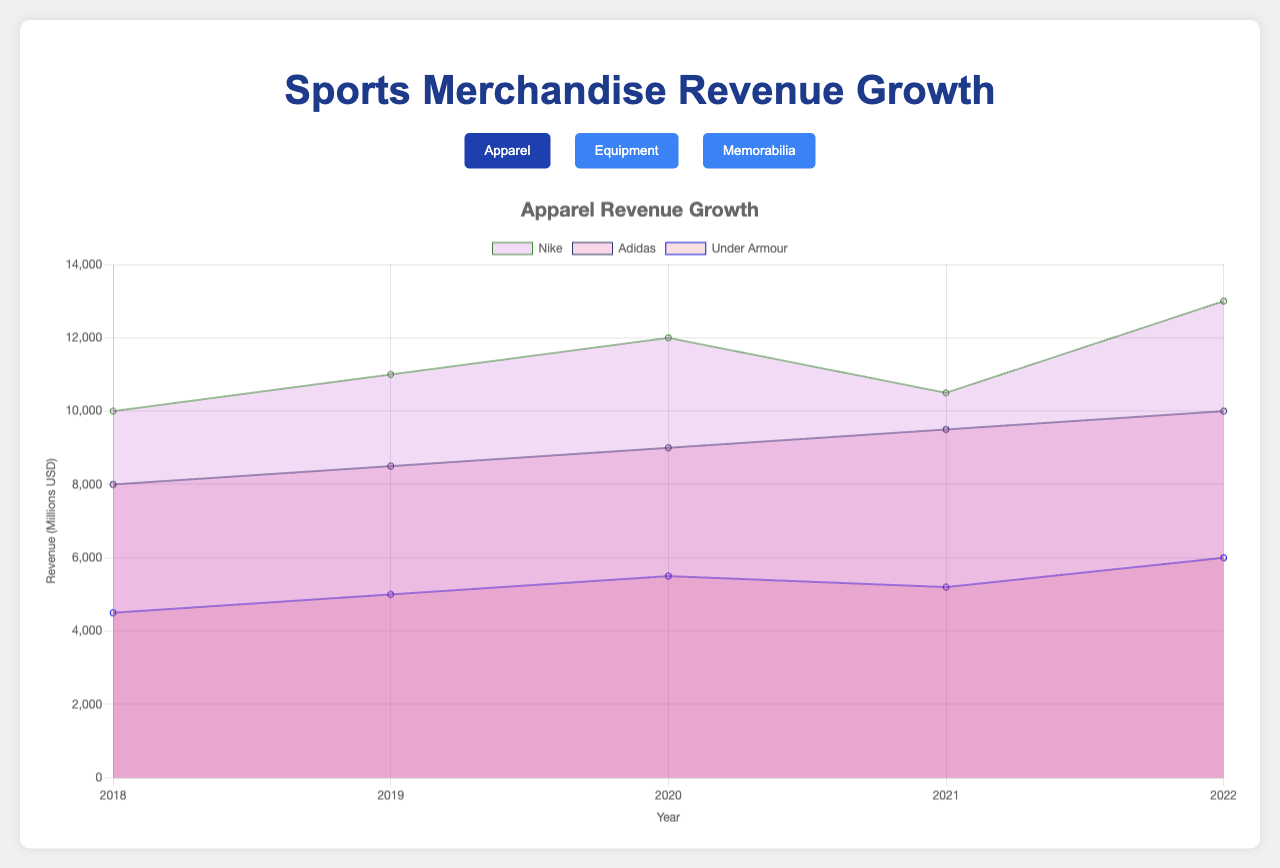Which company in the Apparel category had the highest revenue in 2022? Look for the Apparel category in the legend, then check the revenue values for each company in 2022. Nike's revenue in 2022 stands at 13000, which is higher than Adidas (10000) and Under Armour (6000).
Answer: Nike How did Adidas' revenue in Equipment change from 2018 to 2022? Check the revenue values for Adidas in the Equipment category for the years 2018 and 2022. The revenue in 2018 was 6000, and in 2022 it was 7500. The difference shows an increase over the years.
Answer: Increased by 1500 What's the total revenue change for the Memorabilia category from 2020 to 2021? Sum the revenue values for 2020 and 2021 for all companies in the Memorabilia category. For 2020, the total is 6750 (2000 + 2100 + 1950), and for 2021, it is 7550 (2800 + 2600 + 2150). The change is 7550 - 6750 = 800.
Answer: Increased by 800 Which product category showed the highest overall revenue growth? Compare the total revenue in 2022 for each category (Apparel, Equipment, Memorabilia). Sum the revenues for each category, then identify the category with the highest sum. Apparel's total in 2022 is 29000, Equipment's is 20500, and Memorabilia's is 8900.
Answer: Apparel What were the minimum and maximum revenues for Nike in all categories from 2018 to 2022? Look at Nike's revenue values across all categories and years. The minimum value is 7000 (Equipment in 2018), and the maximum is 13000 (Apparel in 2022).
Answer: Minimum is 7000, Maximum is 13000 Which company's revenue grew the most in the Memorabilia category from 2018 to 2022? Analyze the revenue change for each company in the Memorabilia category between 2018 and 2022. Calculate the difference for Fanatics (3500 - 2000 = 1500), Topps (2900 - 1800 = 1100), and Panini (2500 - 1500 = 1000).
Answer: Fanatics How did Under Armour's revenue in the Apparel category change from 2018 to 2019? Compare Under Armour’s revenue for the Apparel category in 2018 and 2019. The revenue went from 4500 to 5000, indicating an increase.
Answer: Increased by 500 Which year saw the highest revenue for Wilson in the Equipment category? Check Wilson’s revenue values in the Equipment category for each year. The highest revenue, 4000, occurred in 2022.
Answer: 2022 